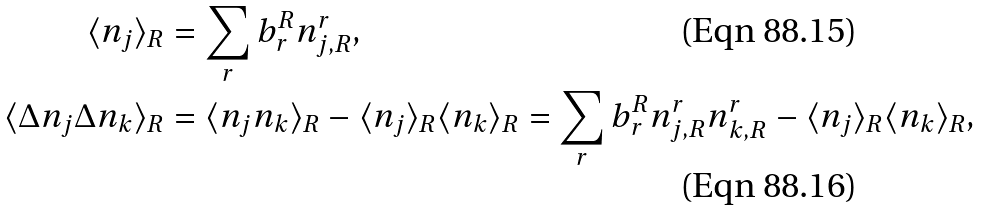Convert formula to latex. <formula><loc_0><loc_0><loc_500><loc_500>\langle n _ { j } \rangle _ { R } & = \sum _ { r } b _ { r } ^ { R } n _ { j , R } ^ { r } , \\ \langle \Delta n _ { j } \Delta n _ { k } \rangle _ { R } & = \langle n _ { j } n _ { k } \rangle _ { R } - \langle n _ { j } \rangle _ { R } \langle n _ { k } \rangle _ { R } = \sum _ { r } b _ { r } ^ { R } n _ { j , R } ^ { r } n _ { k , R } ^ { r } - \langle n _ { j } \rangle _ { R } \langle n _ { k } \rangle _ { R } ,</formula> 